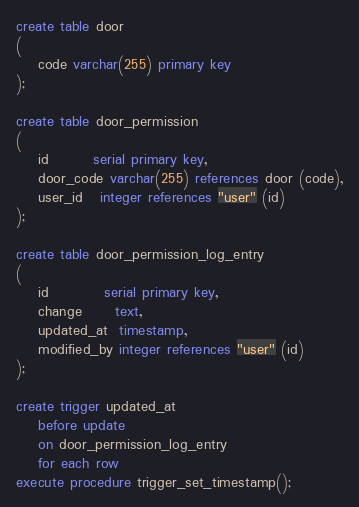<code> <loc_0><loc_0><loc_500><loc_500><_SQL_>create table door
(
    code varchar(255) primary key
);

create table door_permission
(
    id        serial primary key,
    door_code varchar(255) references door (code),
    user_id   integer references "user" (id)
);

create table door_permission_log_entry
(
    id          serial primary key,
    change      text,
    updated_at  timestamp,
    modified_by integer references "user" (id)
);

create trigger updated_at
    before update
    on door_permission_log_entry
    for each row
execute procedure trigger_set_timestamp();</code> 